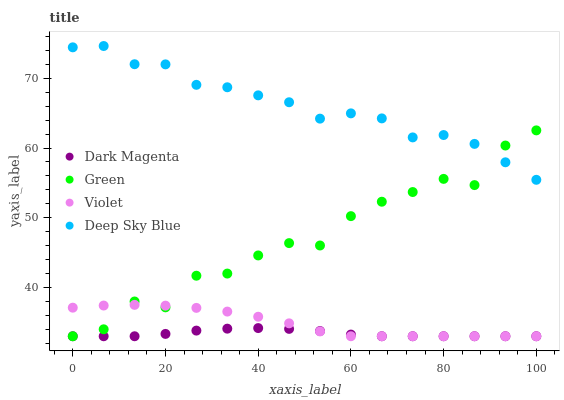Does Dark Magenta have the minimum area under the curve?
Answer yes or no. Yes. Does Deep Sky Blue have the maximum area under the curve?
Answer yes or no. Yes. Does Deep Sky Blue have the minimum area under the curve?
Answer yes or no. No. Does Dark Magenta have the maximum area under the curve?
Answer yes or no. No. Is Dark Magenta the smoothest?
Answer yes or no. Yes. Is Green the roughest?
Answer yes or no. Yes. Is Deep Sky Blue the smoothest?
Answer yes or no. No. Is Deep Sky Blue the roughest?
Answer yes or no. No. Does Green have the lowest value?
Answer yes or no. Yes. Does Deep Sky Blue have the lowest value?
Answer yes or no. No. Does Deep Sky Blue have the highest value?
Answer yes or no. Yes. Does Dark Magenta have the highest value?
Answer yes or no. No. Is Dark Magenta less than Deep Sky Blue?
Answer yes or no. Yes. Is Deep Sky Blue greater than Violet?
Answer yes or no. Yes. Does Green intersect Violet?
Answer yes or no. Yes. Is Green less than Violet?
Answer yes or no. No. Is Green greater than Violet?
Answer yes or no. No. Does Dark Magenta intersect Deep Sky Blue?
Answer yes or no. No. 